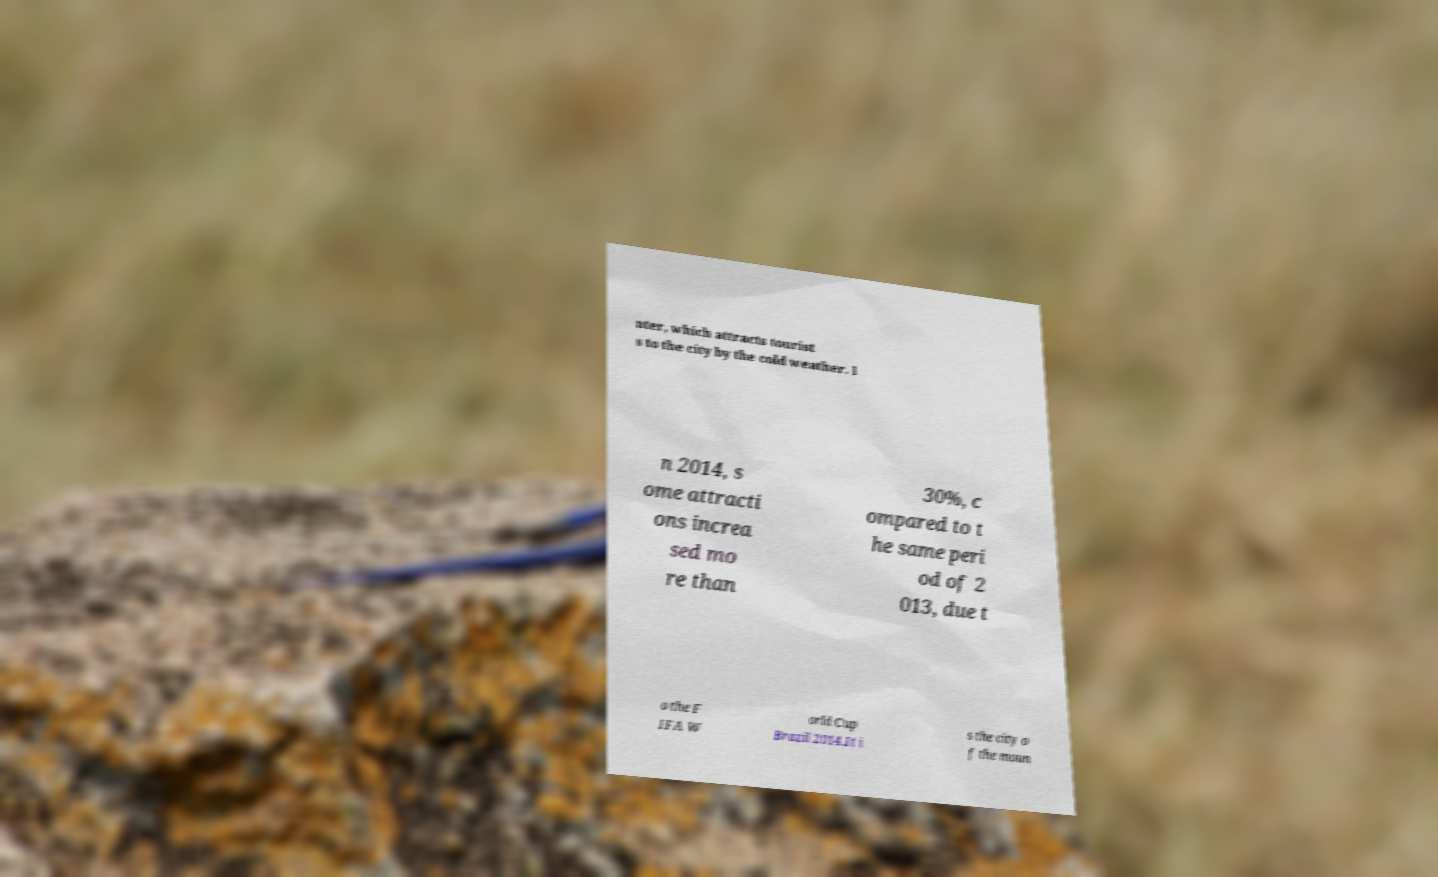What messages or text are displayed in this image? I need them in a readable, typed format. nter, which attracts tourist s to the city by the cold weather. I n 2014, s ome attracti ons increa sed mo re than 30%, c ompared to t he same peri od of 2 013, due t o the F IFA W orld Cup Brazil 2014.It i s the city o f the moun 